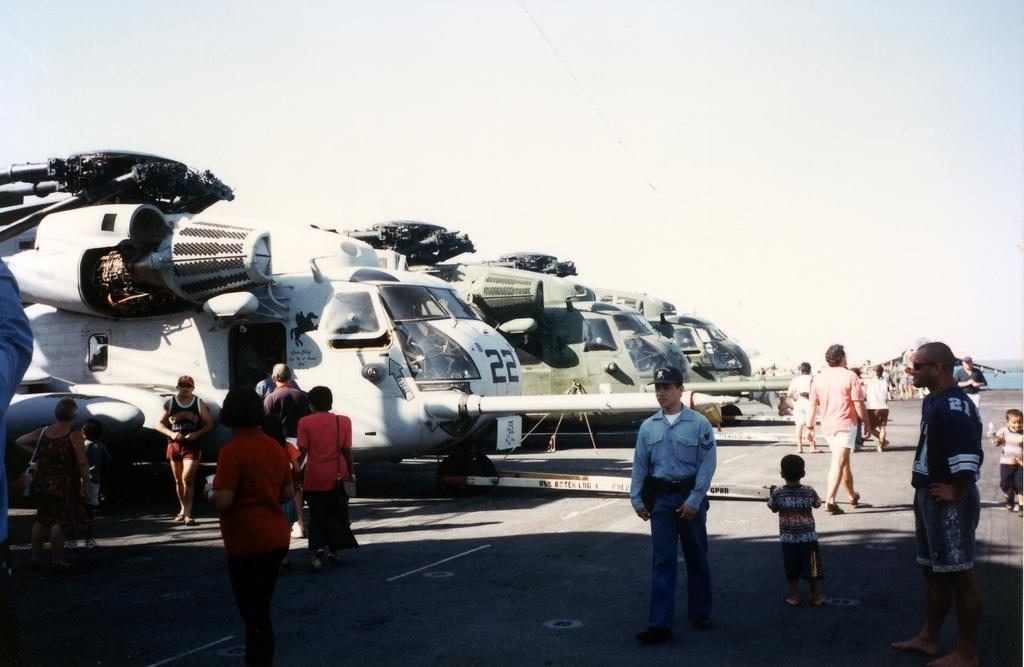What is the main subject of the image? The main subject of the image is airplanes on the runway. Can you describe the colors of the airplanes? Some of the airplanes are white, and others are green. What else can be seen in the image besides airplanes? There are people walking on the runway. What is visible in the background of the image? The sky is visible in the background of the image. What type of cart is being used to transport the cows in the image? There are no carts or cows present in the image; it features airplanes on the runway with people walking nearby. 